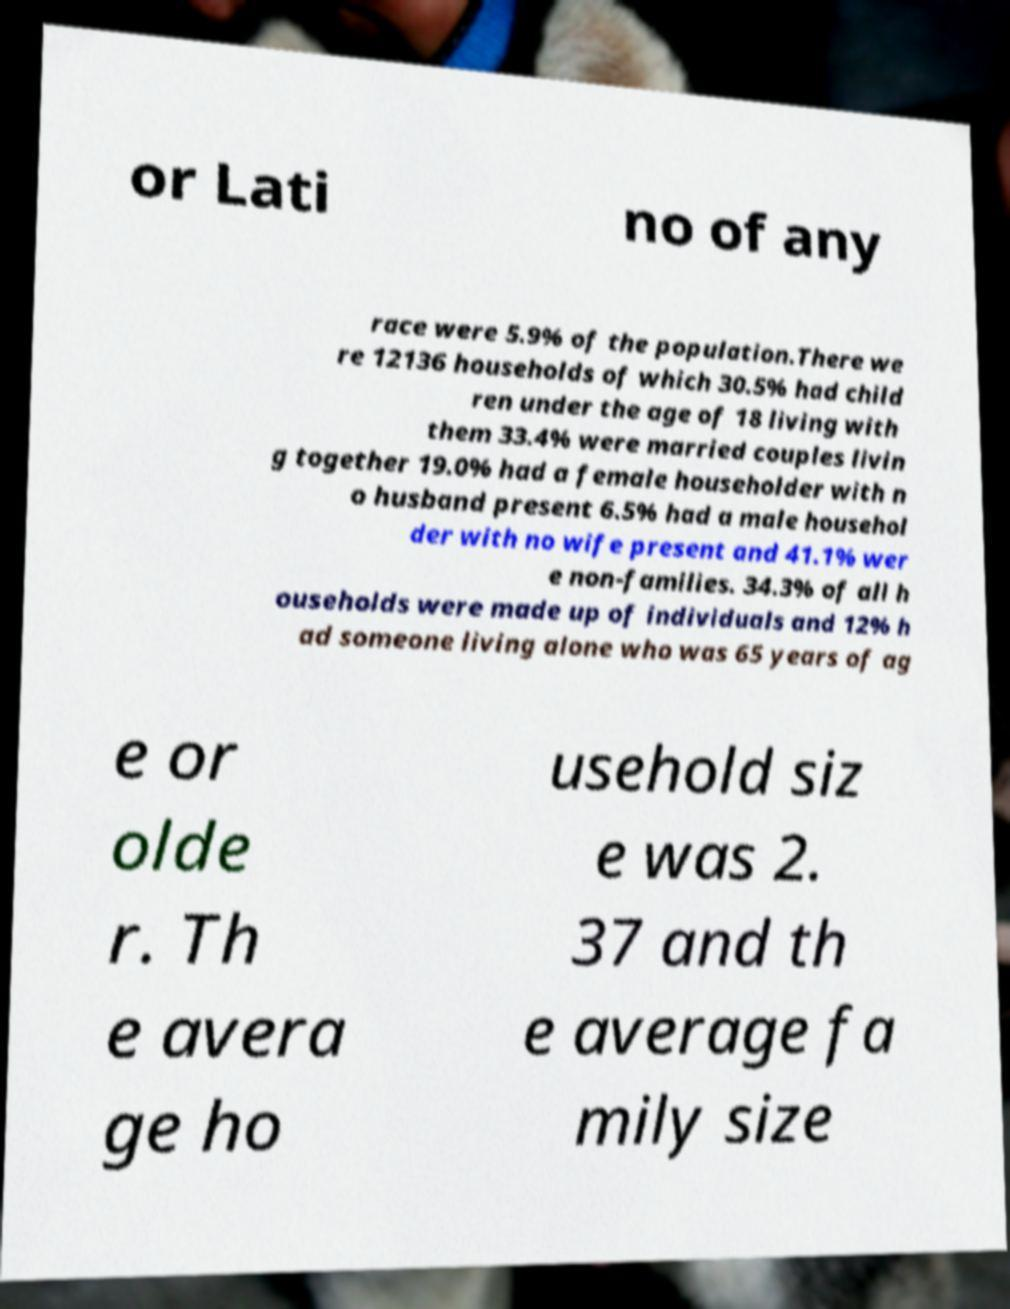Please read and relay the text visible in this image. What does it say? or Lati no of any race were 5.9% of the population.There we re 12136 households of which 30.5% had child ren under the age of 18 living with them 33.4% were married couples livin g together 19.0% had a female householder with n o husband present 6.5% had a male househol der with no wife present and 41.1% wer e non-families. 34.3% of all h ouseholds were made up of individuals and 12% h ad someone living alone who was 65 years of ag e or olde r. Th e avera ge ho usehold siz e was 2. 37 and th e average fa mily size 